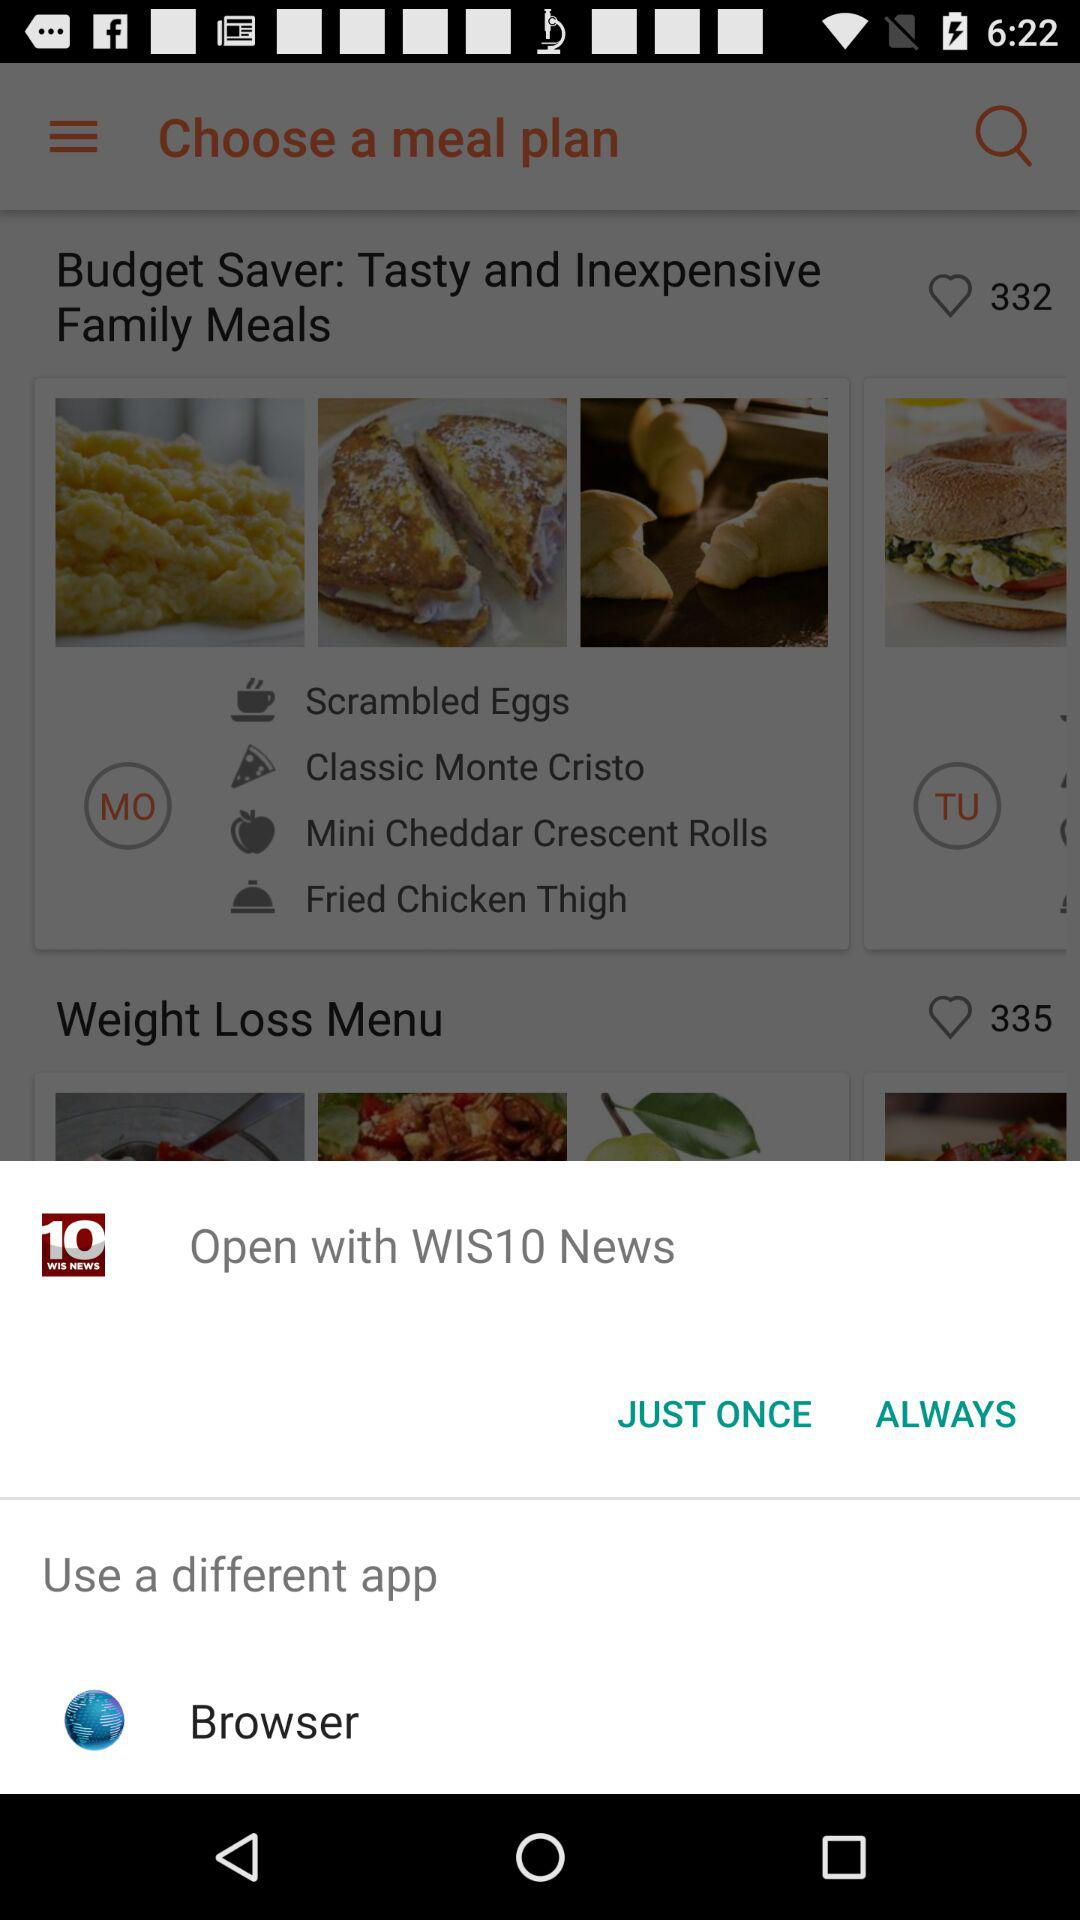How many meal plans are available?
Answer the question using a single word or phrase. 2 